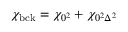Convert formula to latex. <formula><loc_0><loc_0><loc_500><loc_500>\chi _ { b c k } = \chi _ { 0 ^ { 2 } } + \chi _ { 0 ^ { 2 } \Delta ^ { 2 } }</formula> 